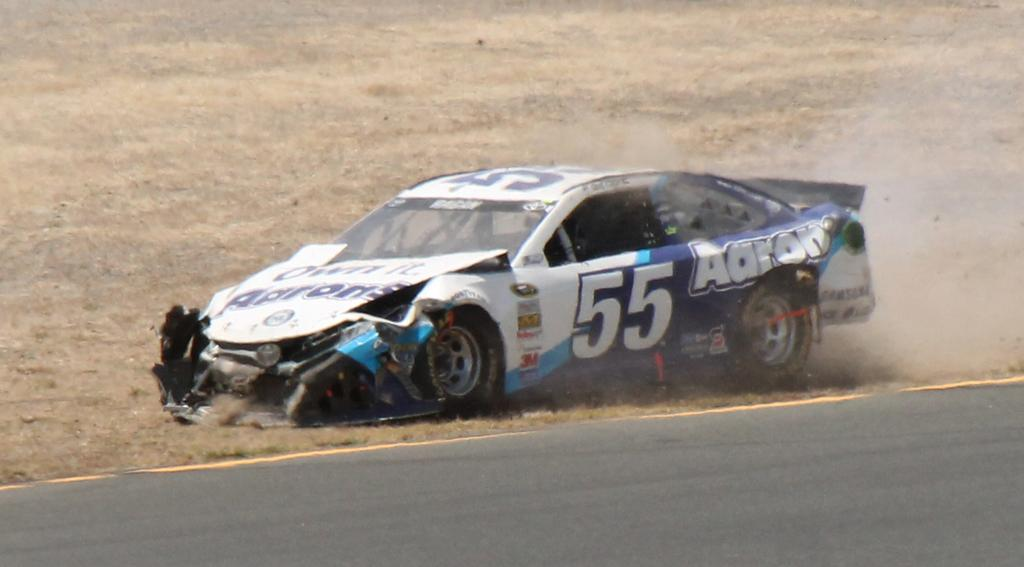Where was the image taken? The image was taken outdoors. What can be seen at the bottom of the image? There is a road at the bottom of the image. What is located in the middle of the image? A car is parked in the middle of the image. What is the position of the car in the image? The car is on the ground. What type of cherry is hanging from the car's antenna in the image? There is no cherry present on the car's antenna in the image. Is there a crook in the image, and if so, where is it located? There is no crook present in the image. 